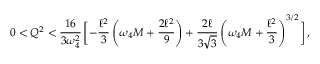Convert formula to latex. <formula><loc_0><loc_0><loc_500><loc_500>0 < Q ^ { 2 } < \frac { 1 6 } { 3 \omega _ { 4 } ^ { 2 } } \, \left [ - \frac { \ell ^ { 2 } } { 3 } \left ( \omega _ { 4 } M + \frac { 2 \ell ^ { 2 } } { 9 } \right ) + \frac { 2 \ell } { 3 \sqrt { 3 } } \left ( \omega _ { 4 } M + \frac { \ell ^ { 2 } } { 3 } \right ) ^ { 3 / 2 } \right ] \, ,</formula> 